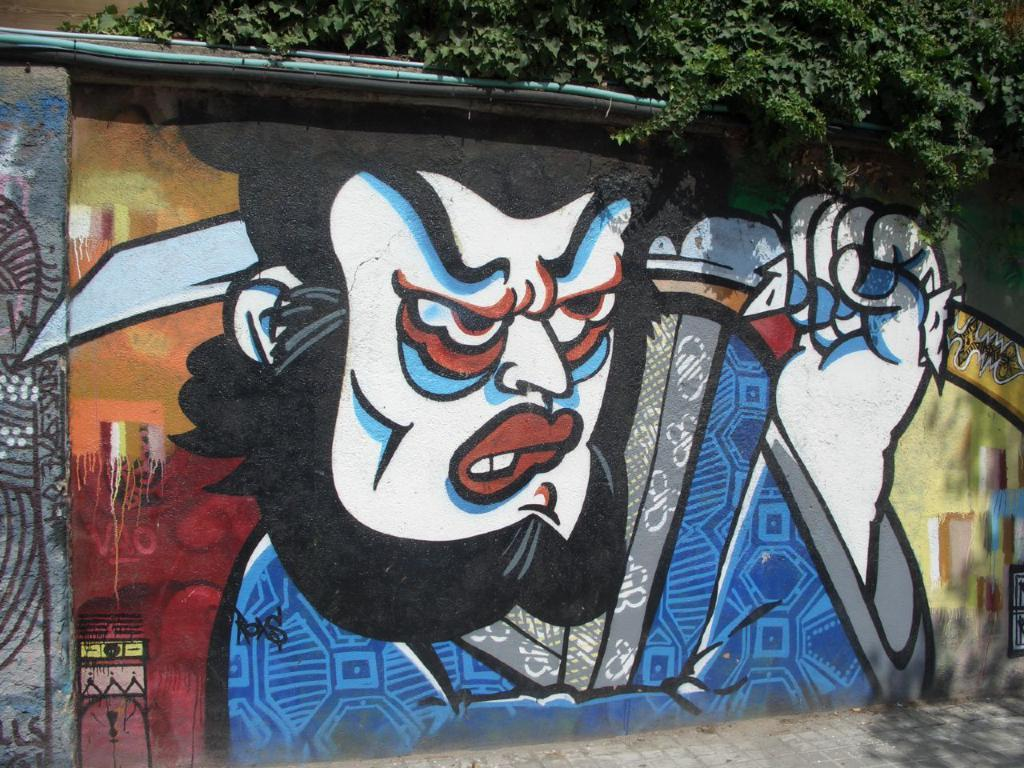What can be seen on the wall in the image? There is a painting on the wall in the image. What type of path is visible in the image? There is a footpath in the image. What natural element is present in the image? There is a tree in the image. How many horses are depicted in the painting on the wall? There is no information about horses in the image or the painting on the wall. What other things can be seen in the image besides the wall, painting, footpath, and tree? The provided facts do not mention any other objects or elements in the image, so we cannot answer this question definitively. 